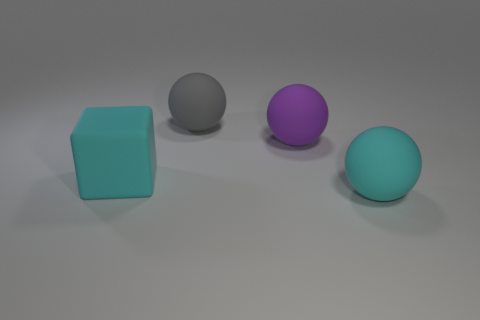What shape is the big purple rubber thing that is behind the big rubber ball in front of the big purple sphere?
Your answer should be very brief. Sphere. What number of other things are the same shape as the purple object?
Make the answer very short. 2. Is the color of the matte sphere that is to the right of the purple rubber sphere the same as the large cube?
Your answer should be compact. Yes. Is there a big rubber sphere that has the same color as the cube?
Provide a short and direct response. Yes. How many cubes are to the right of the big matte cube?
Provide a succinct answer. 0. How many other things are the same size as the cyan rubber cube?
Offer a terse response. 3. What is the color of the cube that is the same size as the purple rubber thing?
Provide a short and direct response. Cyan. Is there anything else that has the same color as the matte cube?
Make the answer very short. Yes. What size is the cyan object that is to the right of the large cyan matte object that is left of the cyan matte object right of the cyan rubber block?
Your answer should be compact. Large. What color is the big matte thing that is both in front of the big purple rubber thing and on the right side of the big cyan rubber cube?
Ensure brevity in your answer.  Cyan. 